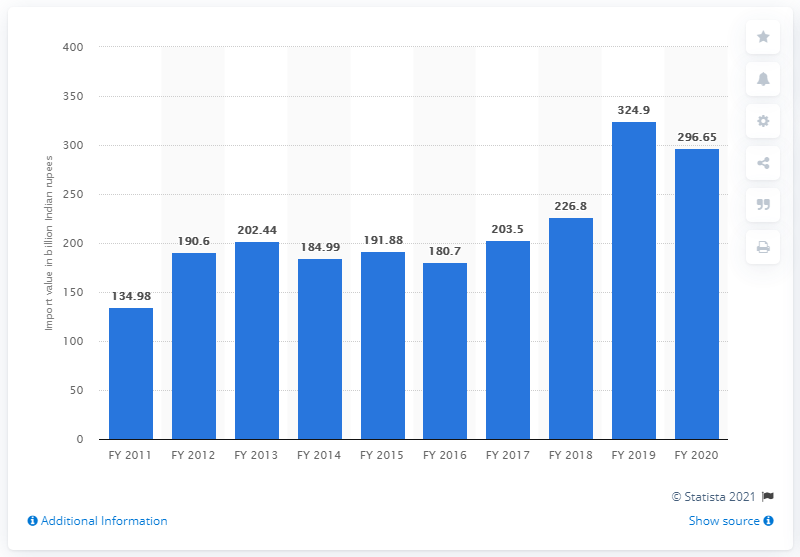Outline some significant characteristics in this image. In the fiscal year 2020, India imported a total of 296.65 million Indian rupees worth of machine tools. India's machine tools were previously valued at 324.9 million USD. 